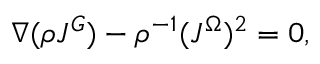Convert formula to latex. <formula><loc_0><loc_0><loc_500><loc_500>\nabla ( \rho J ^ { G } ) - \rho ^ { - 1 } ( J ^ { \Omega } ) ^ { 2 } = 0 ,</formula> 